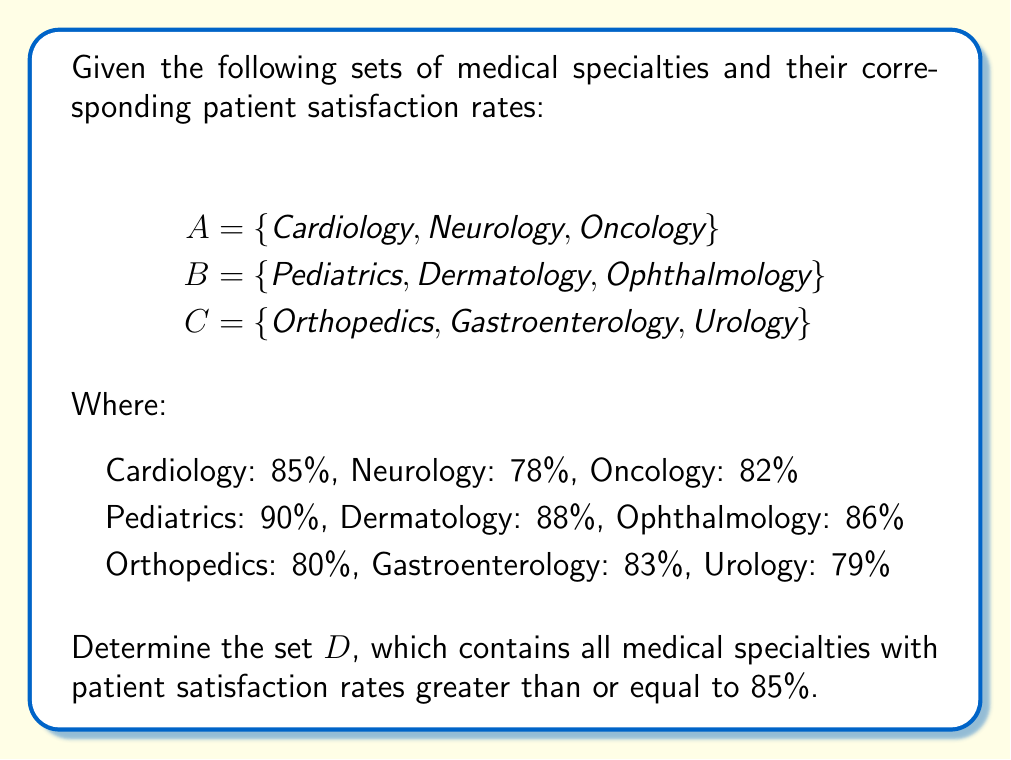Can you solve this math problem? To solve this problem, we need to follow these steps:

1. Identify the specialties in each set that meet the criteria (satisfaction rate ≥ 85%):

Set A:
- Cardiology: 85% ≥ 85%, so it's included
- Neurology: 78% < 85%, not included
- Oncology: 82% < 85%, not included

Set B:
- Pediatrics: 90% > 85%, so it's included
- Dermatology: 88% > 85%, so it's included
- Ophthalmology: 86% > 85%, so it's included

Set C:
- Orthopedics: 80% < 85%, not included
- Gastroenterology: 83% < 85%, not included
- Urology: 79% < 85%, not included

2. Combine the specialties that meet the criteria into a new set D:

$$D = \{x \in A \cup B \cup C : \text{satisfaction rate}(x) \geq 85\%\}$$

3. List the elements of set D:

$$D = \{\text{Cardiology}, \text{Pediatrics}, \text{Dermatology}, \text{Ophthalmology}\}$$

This new set D contains all the medical specialties from sets A, B, and C that have patient satisfaction rates greater than or equal to 85%.
Answer: $$D = \{\text{Cardiology}, \text{Pediatrics}, \text{Dermatology}, \text{Ophthalmology}\}$$ 